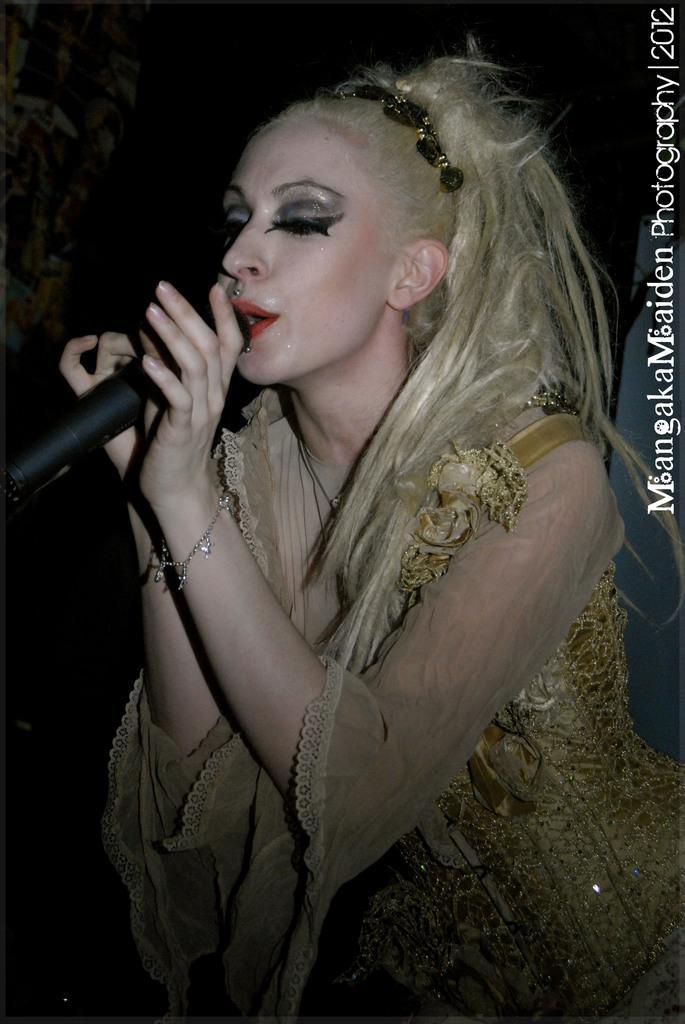How would you summarize this image in a sentence or two? In this picture we can see woman holding mic in her hand and singing and she wore hair band, bracelet, nice dress. 